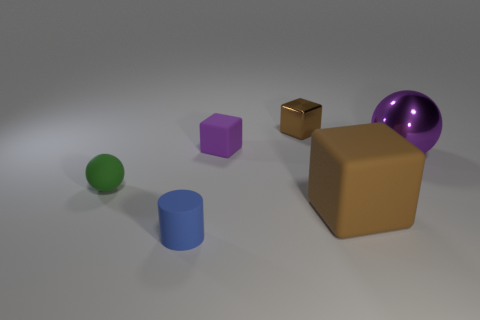Subtract all matte cubes. How many cubes are left? 1 Add 3 purple cubes. How many objects exist? 9 Subtract all purple cubes. How many cubes are left? 2 Subtract 1 spheres. How many spheres are left? 1 Add 6 tiny rubber spheres. How many tiny rubber spheres exist? 7 Subtract 1 blue cylinders. How many objects are left? 5 Subtract all cylinders. How many objects are left? 5 Subtract all gray spheres. Subtract all yellow blocks. How many spheres are left? 2 Subtract all green cylinders. How many purple blocks are left? 1 Subtract all blue metal cubes. Subtract all tiny matte objects. How many objects are left? 3 